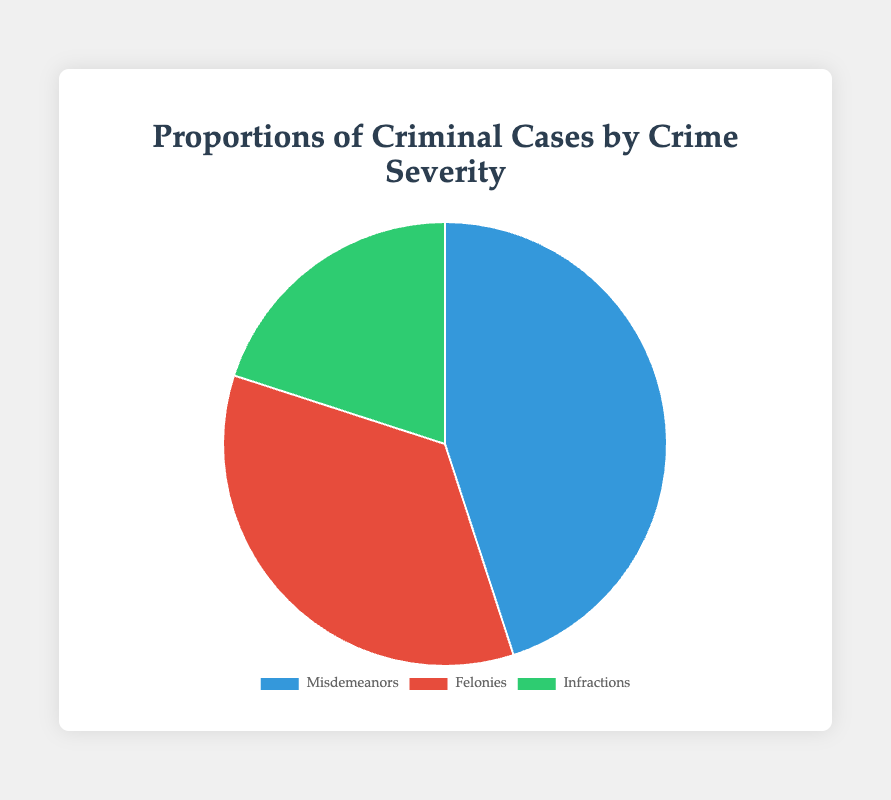What is the largest category in the pie chart? The Misdemeanors category has the highest proportion at 45%, making it the largest segment in the pie chart.
Answer: Misdemeanors Which category covers the smallest portion of the pie chart? The Infractions category covers the smallest portion of the pie chart with a proportion of 20%.
Answer: Infractions How much greater is the proportion of Misdemeanors compared to Infractions? The proportion of Misdemeanors (45%) compared to Infractions (20%) can be calculated by finding the difference: 45% - 20% = 25%.
Answer: 25% Calculate the total proportion of Misdemeanors and Felonies together. Adding the proportions of Misdemeanors (45%) and Felonies (35%) gives 45% + 35% = 80%.
Answer: 80% Which category is represented by the color blue? The color blue visually represents the category ‘Misdemeanors’.
Answer: Misdemeanors By how much does the Misdemeanors category exceed the average proportion of all categories? First, calculate the average proportion: (45% + 35% + 20%) / 3 = 33.33%. The difference between Misdemeanors proportion (45%) and the average is: 45% - 33.33% ≈ 11.67%.
Answer: ≈ 11.67% Is the proportion of Felonies greater than half of the proportion of Misdemeanors? Half of the proportion of Misdemeanors is 45% / 2 = 22.5%. Since Felonies is 35%, which is indeed greater than 22.5%.
Answer: Yes Compare the combined proportion of Infractions and Felonies to Misdemeanors. The combined proportion of Infractions (20%) and Felonies (35%) is 20% + 35% = 55%, which is greater than Misdemeanors (45%).
Answer: Infractions and Felonies combined What is the proportion of crimes that are not Misdemeanors? To find the proportion of crimes that are not Misdemeanors, add the proportions of Felonies (35%) and Infractions (20%): 35% + 20% = 55%.
Answer: 55% If the proportion of Infractions were to increase by 10%, what would the new total proportion for all categories be? Increasing Infractions by 10%: 20% + 10% = 30%. The new total proportion would be 45% (Misdemeanors) + 35% (Felonies) + 30% (Infractions) = 110%.
Answer: 110% 